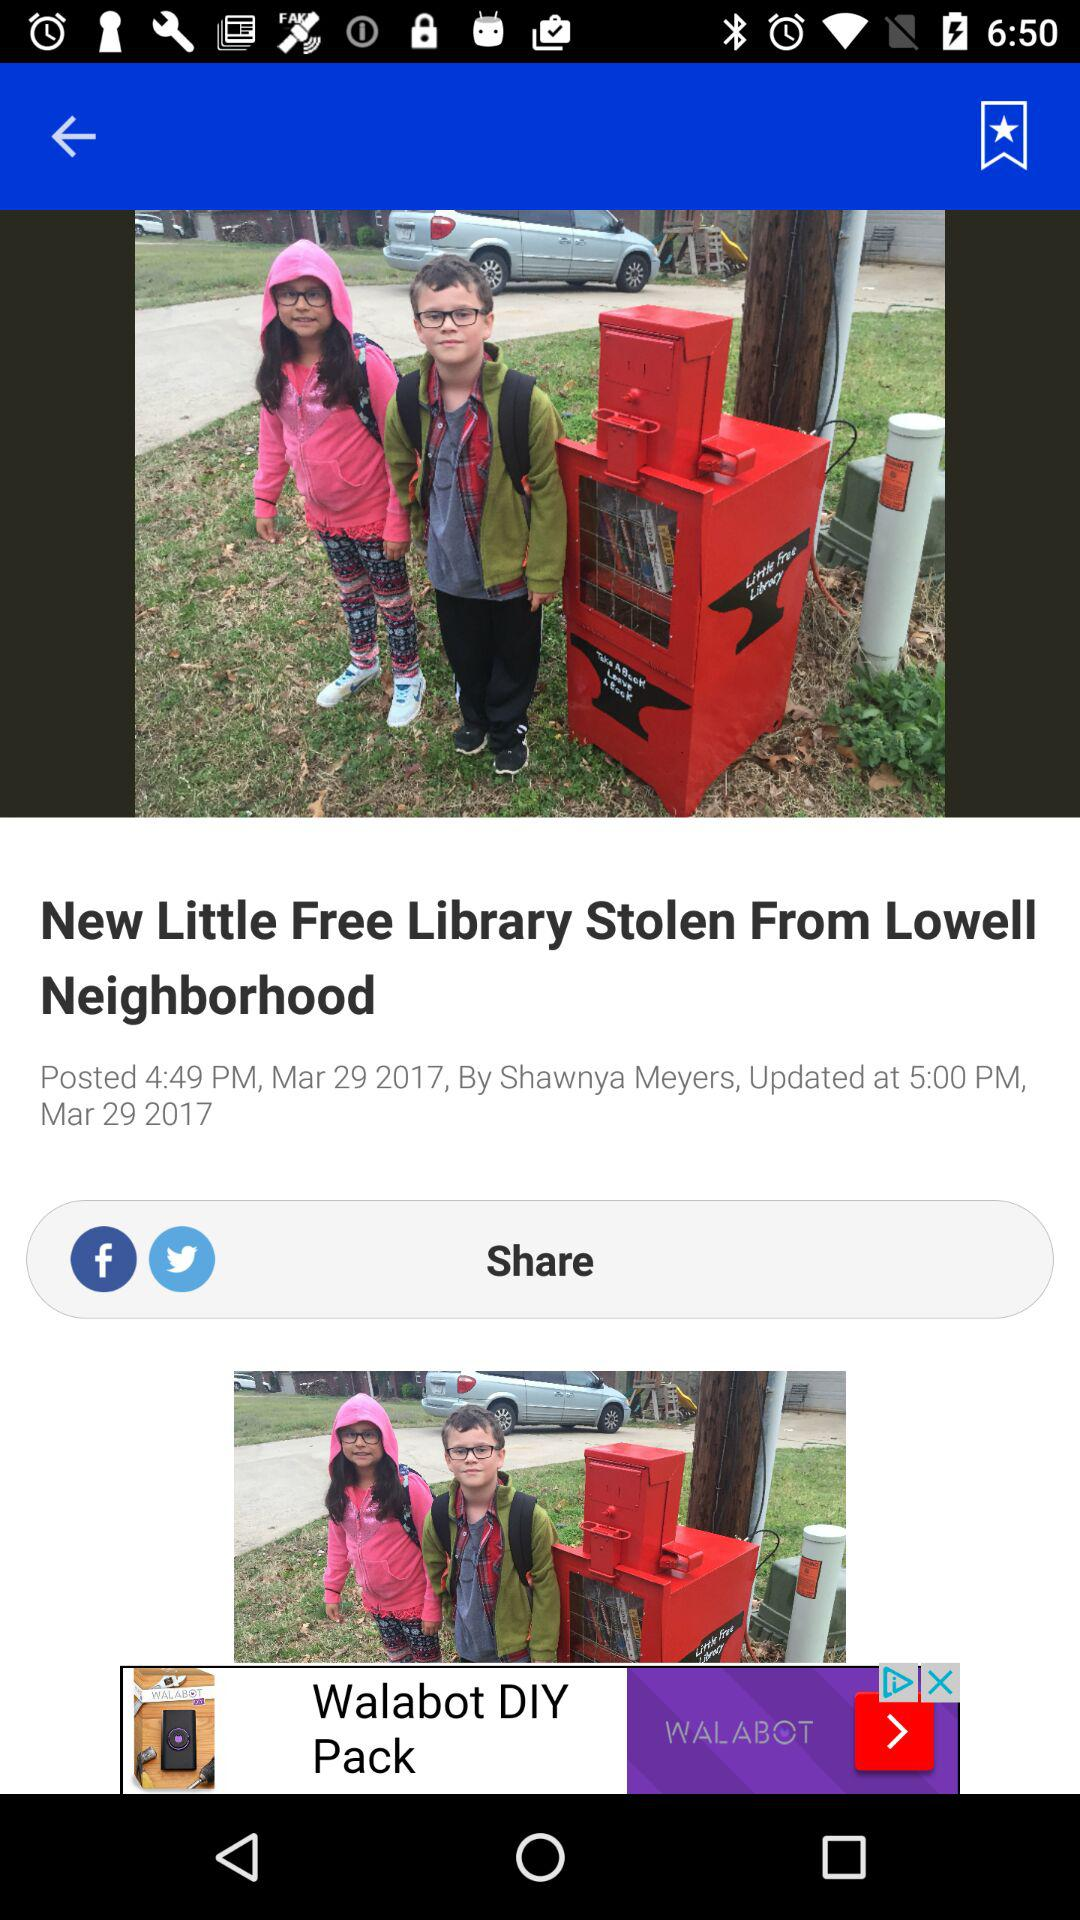What is the updated time of the article? The updated time of the article is 5 p.m. 